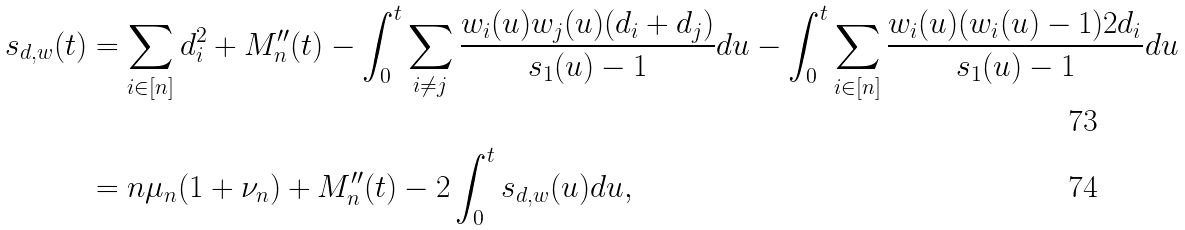<formula> <loc_0><loc_0><loc_500><loc_500>s _ { d , w } ( t ) & = \sum _ { i \in [ n ] } d _ { i } ^ { 2 } + M _ { n } ^ { \prime \prime } ( t ) - \int _ { 0 } ^ { t } \sum _ { i \neq j } \frac { w _ { i } ( u ) w _ { j } ( u ) ( d _ { i } + d _ { j } ) } { s _ { 1 } ( u ) - 1 } d u - \int _ { 0 } ^ { t } \sum _ { i \in [ n ] } \frac { w _ { i } ( u ) ( w _ { i } ( u ) - 1 ) 2 d _ { i } } { s _ { 1 } ( u ) - 1 } d u \\ & = n \mu _ { n } ( 1 + \nu _ { n } ) + M _ { n } ^ { \prime \prime } ( t ) - 2 \int _ { 0 } ^ { t } s _ { d , w } ( u ) d u ,</formula> 